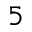Convert formula to latex. <formula><loc_0><loc_0><loc_500><loc_500>5</formula> 